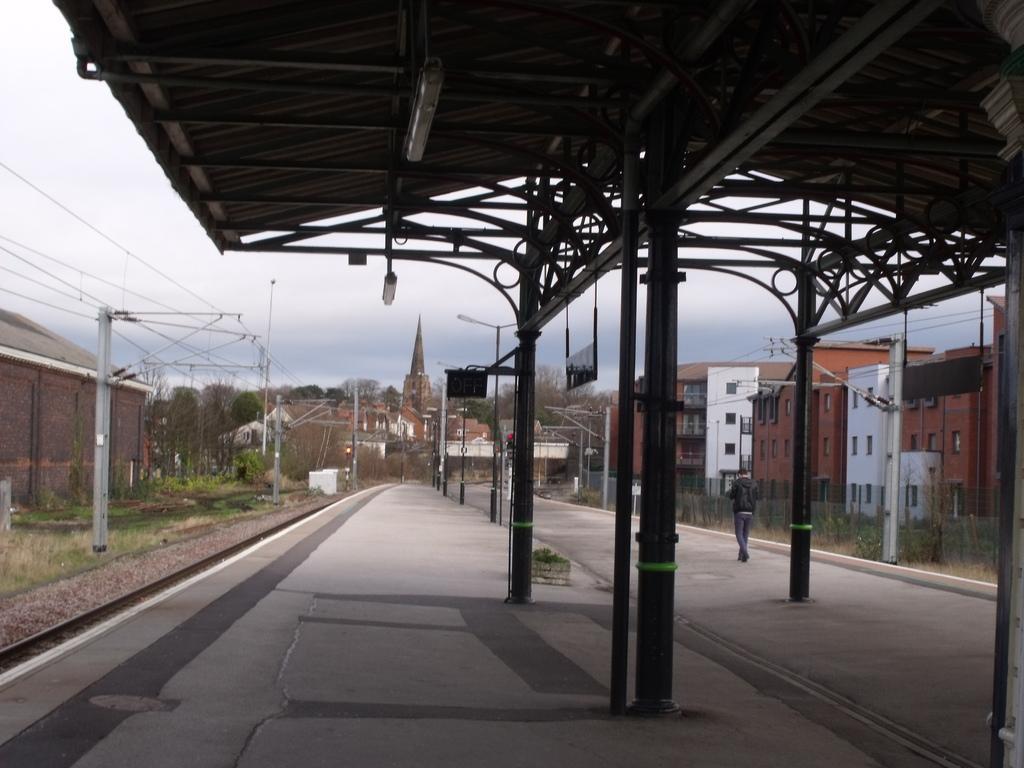Could you give a brief overview of what you see in this image? This picture is clicked outside. In the foreground we can see the metal rods, roof, lights and a person walking on the ground. On the left we can see the railway track, cables, poles, grass and in the background we can see the sky, some houses, buildings, trees and a spire and light attached to the pole and many other objects. 